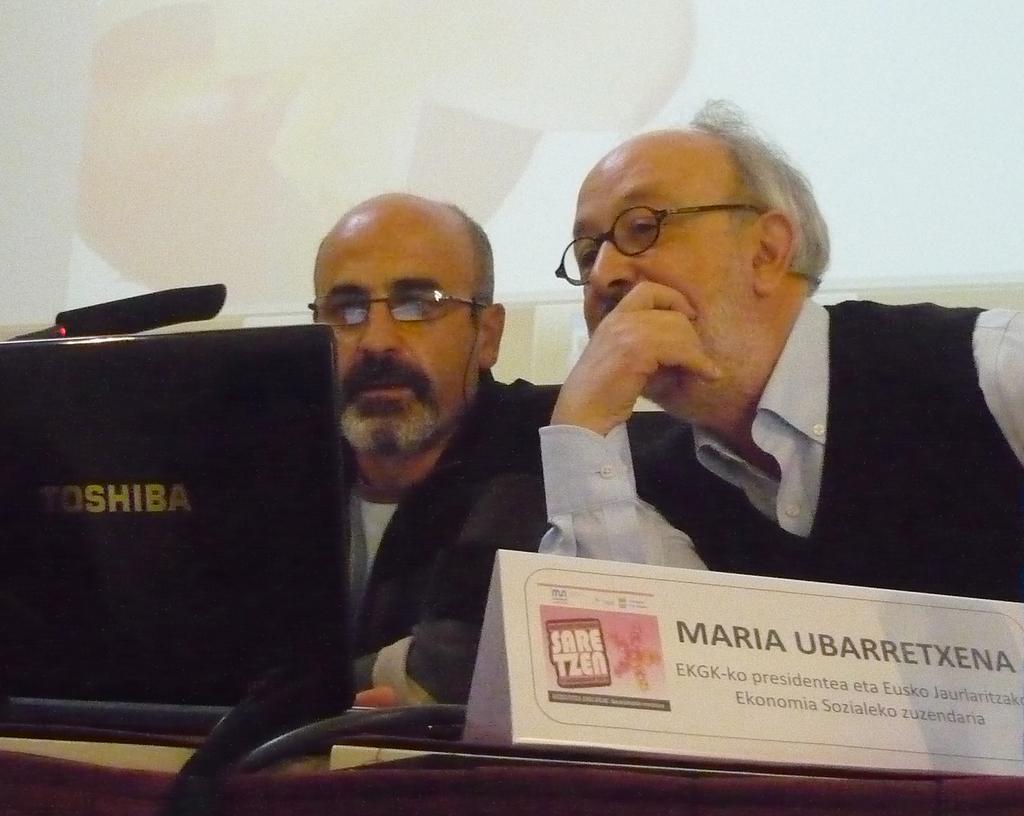Could you give a brief overview of what you see in this image? At the bottom there is a table on which a name board, wires and a monitor are placed. On the right side there are two men looking into the monitor. In the background there is a screen. 